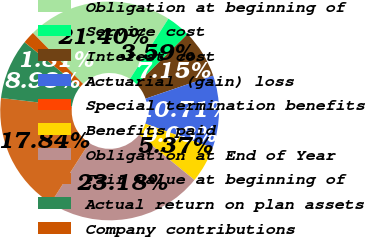<chart> <loc_0><loc_0><loc_500><loc_500><pie_chart><fcel>Obligation at beginning of<fcel>Service cost<fcel>Interest cost<fcel>Actuarial (gain) loss<fcel>Special termination benefits<fcel>Benefits paid<fcel>Obligation at End of Year<fcel>Fair value at beginning of<fcel>Actual return on plan assets<fcel>Company contributions<nl><fcel>21.4%<fcel>3.59%<fcel>7.15%<fcel>10.71%<fcel>0.03%<fcel>5.37%<fcel>23.18%<fcel>17.84%<fcel>8.93%<fcel>1.81%<nl></chart> 